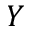<formula> <loc_0><loc_0><loc_500><loc_500>Y</formula> 